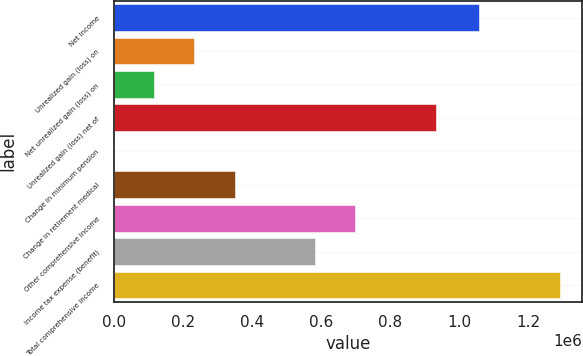Convert chart to OTSL. <chart><loc_0><loc_0><loc_500><loc_500><bar_chart><fcel>Net income<fcel>Unrealized gain (loss) on<fcel>Net unrealized gain (loss) on<fcel>Unrealized gain (loss) net of<fcel>Change in minimum pension<fcel>Change in retirement medical<fcel>Other comprehensive income<fcel>Income tax expense (benefit)<fcel>Total comprehensive income<nl><fcel>1.0597e+06<fcel>233337<fcel>116704<fcel>933134<fcel>71<fcel>349970<fcel>699868<fcel>583236<fcel>1.29297e+06<nl></chart> 